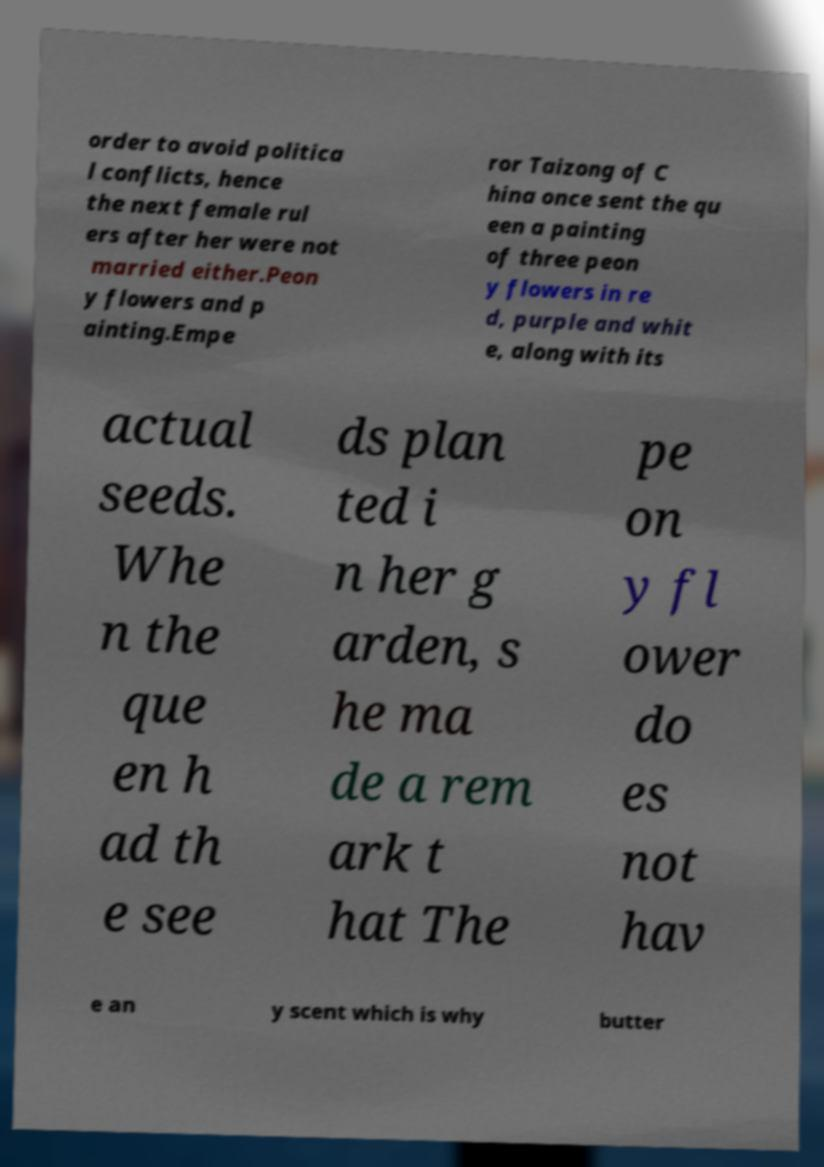Can you read and provide the text displayed in the image?This photo seems to have some interesting text. Can you extract and type it out for me? order to avoid politica l conflicts, hence the next female rul ers after her were not married either.Peon y flowers and p ainting.Empe ror Taizong of C hina once sent the qu een a painting of three peon y flowers in re d, purple and whit e, along with its actual seeds. Whe n the que en h ad th e see ds plan ted i n her g arden, s he ma de a rem ark t hat The pe on y fl ower do es not hav e an y scent which is why butter 